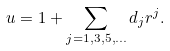<formula> <loc_0><loc_0><loc_500><loc_500>u = 1 + \sum _ { j = 1 , 3 , 5 , \dots } d _ { j } r ^ { j } .</formula> 